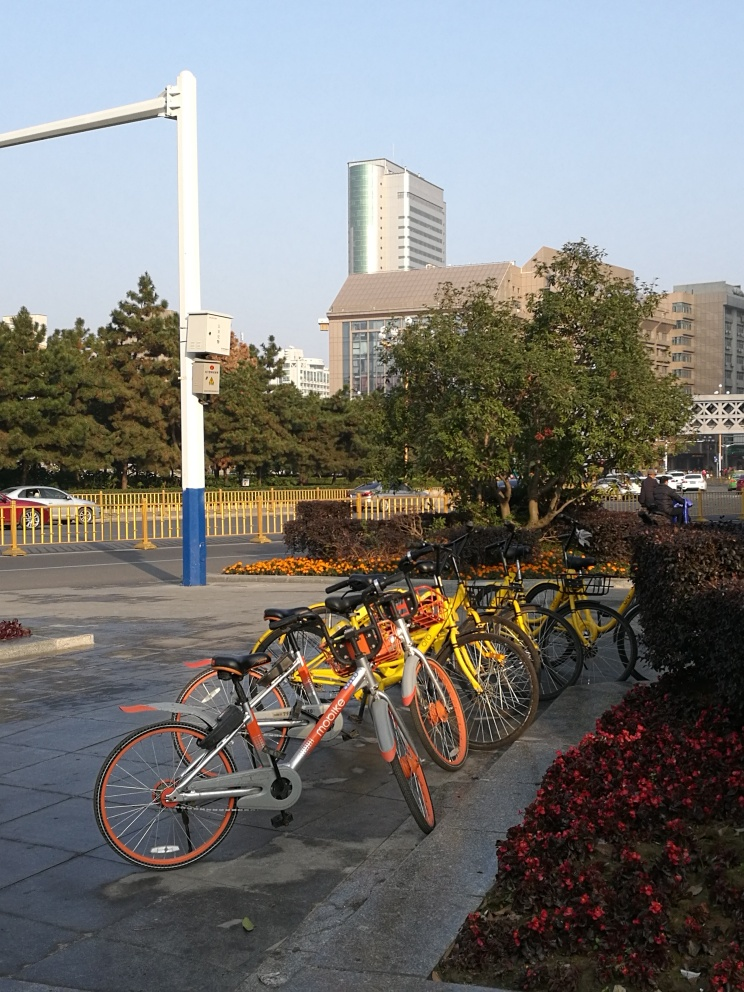Is there any chromatic aberration in the photo? Chromatic aberration is typically observed as color fringes around the edges of objects, especially in high-contrast situations. After careful observation, it appears that there is no noticeable chromatic aberration in this photo. The photo maintains good color fidelity throughout, with no obvious color bleeding or fringing at object edges. 